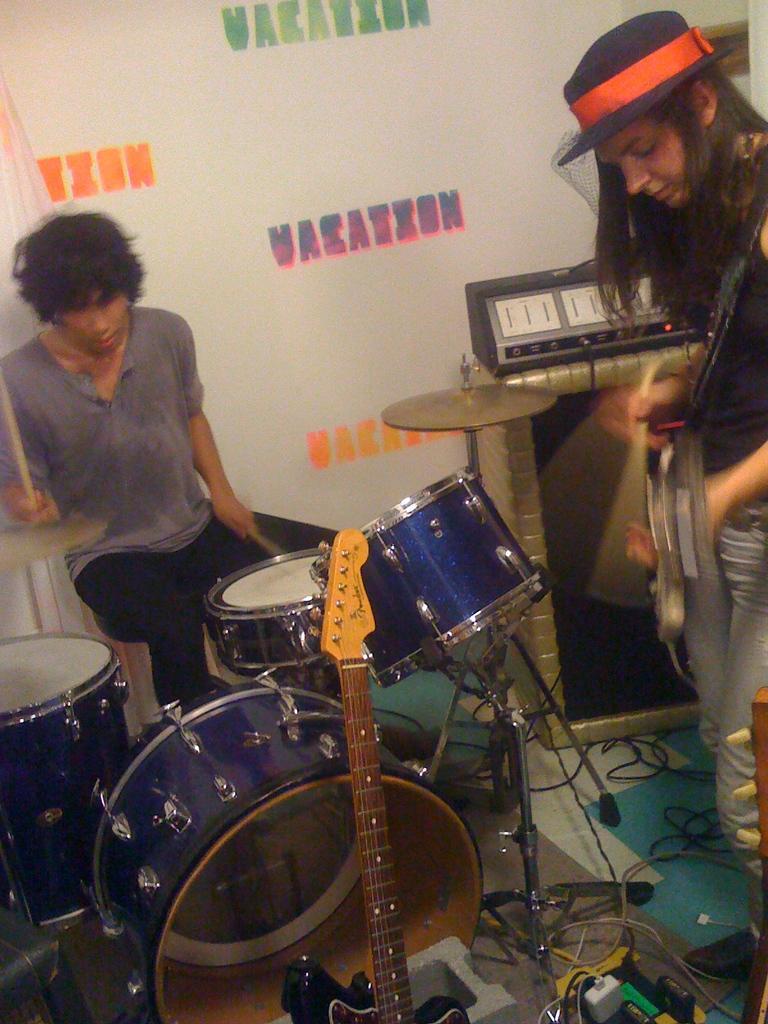Could you give a brief overview of what you see in this image? In this image I can see two persons. The person at left is playing few musical instruments and I can see the white color background and something is written on it. 